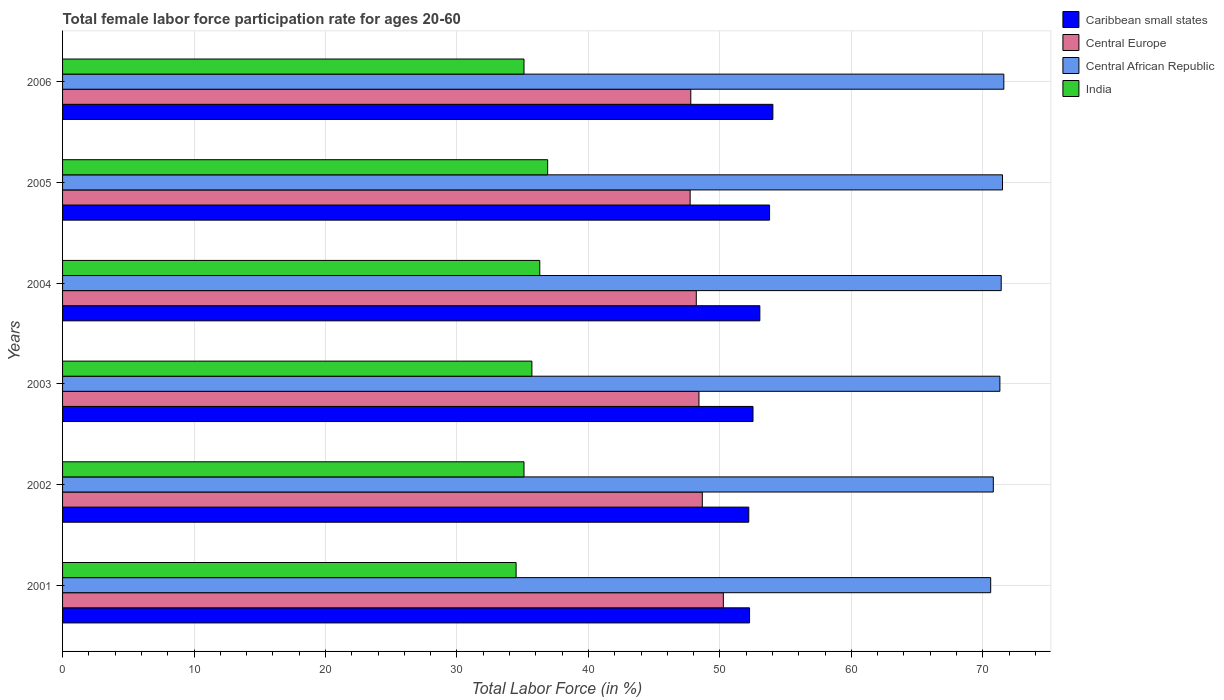How many different coloured bars are there?
Give a very brief answer. 4. Are the number of bars per tick equal to the number of legend labels?
Keep it short and to the point. Yes. Are the number of bars on each tick of the Y-axis equal?
Make the answer very short. Yes. In how many cases, is the number of bars for a given year not equal to the number of legend labels?
Your answer should be compact. 0. What is the female labor force participation rate in Central Europe in 2002?
Your answer should be compact. 48.66. Across all years, what is the maximum female labor force participation rate in Caribbean small states?
Keep it short and to the point. 54.03. Across all years, what is the minimum female labor force participation rate in Central Europe?
Make the answer very short. 47.74. What is the total female labor force participation rate in Central African Republic in the graph?
Provide a short and direct response. 427.2. What is the difference between the female labor force participation rate in Caribbean small states in 2003 and that in 2005?
Provide a succinct answer. -1.26. What is the difference between the female labor force participation rate in Caribbean small states in 2004 and the female labor force participation rate in Central African Republic in 2002?
Provide a short and direct response. -17.76. What is the average female labor force participation rate in Caribbean small states per year?
Make the answer very short. 52.97. In the year 2003, what is the difference between the female labor force participation rate in Central African Republic and female labor force participation rate in India?
Your response must be concise. 35.6. What is the ratio of the female labor force participation rate in India in 2001 to that in 2006?
Keep it short and to the point. 0.98. Is the female labor force participation rate in Central Europe in 2004 less than that in 2005?
Your response must be concise. No. Is the difference between the female labor force participation rate in Central African Republic in 2003 and 2005 greater than the difference between the female labor force participation rate in India in 2003 and 2005?
Provide a succinct answer. Yes. What is the difference between the highest and the second highest female labor force participation rate in India?
Provide a short and direct response. 0.6. What is the difference between the highest and the lowest female labor force participation rate in India?
Provide a short and direct response. 2.4. In how many years, is the female labor force participation rate in Central Europe greater than the average female labor force participation rate in Central Europe taken over all years?
Your answer should be very brief. 2. Is the sum of the female labor force participation rate in India in 2001 and 2005 greater than the maximum female labor force participation rate in Caribbean small states across all years?
Offer a very short reply. Yes. What does the 3rd bar from the top in 2005 represents?
Your answer should be compact. Central Europe. What does the 1st bar from the bottom in 2004 represents?
Your response must be concise. Caribbean small states. Is it the case that in every year, the sum of the female labor force participation rate in Central African Republic and female labor force participation rate in Central Europe is greater than the female labor force participation rate in India?
Your answer should be compact. Yes. Are all the bars in the graph horizontal?
Give a very brief answer. Yes. How many legend labels are there?
Offer a terse response. 4. What is the title of the graph?
Offer a very short reply. Total female labor force participation rate for ages 20-60. Does "Qatar" appear as one of the legend labels in the graph?
Provide a short and direct response. No. What is the label or title of the Y-axis?
Ensure brevity in your answer.  Years. What is the Total Labor Force (in %) in Caribbean small states in 2001?
Your answer should be compact. 52.26. What is the Total Labor Force (in %) in Central Europe in 2001?
Ensure brevity in your answer.  50.26. What is the Total Labor Force (in %) in Central African Republic in 2001?
Ensure brevity in your answer.  70.6. What is the Total Labor Force (in %) of India in 2001?
Your response must be concise. 34.5. What is the Total Labor Force (in %) in Caribbean small states in 2002?
Offer a very short reply. 52.2. What is the Total Labor Force (in %) of Central Europe in 2002?
Give a very brief answer. 48.66. What is the Total Labor Force (in %) in Central African Republic in 2002?
Offer a terse response. 70.8. What is the Total Labor Force (in %) of India in 2002?
Make the answer very short. 35.1. What is the Total Labor Force (in %) of Caribbean small states in 2003?
Your answer should be very brief. 52.52. What is the Total Labor Force (in %) in Central Europe in 2003?
Provide a short and direct response. 48.41. What is the Total Labor Force (in %) of Central African Republic in 2003?
Ensure brevity in your answer.  71.3. What is the Total Labor Force (in %) in India in 2003?
Offer a terse response. 35.7. What is the Total Labor Force (in %) of Caribbean small states in 2004?
Provide a succinct answer. 53.04. What is the Total Labor Force (in %) of Central Europe in 2004?
Make the answer very short. 48.21. What is the Total Labor Force (in %) in Central African Republic in 2004?
Make the answer very short. 71.4. What is the Total Labor Force (in %) in India in 2004?
Provide a short and direct response. 36.3. What is the Total Labor Force (in %) of Caribbean small states in 2005?
Make the answer very short. 53.78. What is the Total Labor Force (in %) in Central Europe in 2005?
Provide a short and direct response. 47.74. What is the Total Labor Force (in %) in Central African Republic in 2005?
Give a very brief answer. 71.5. What is the Total Labor Force (in %) of India in 2005?
Offer a terse response. 36.9. What is the Total Labor Force (in %) in Caribbean small states in 2006?
Offer a very short reply. 54.03. What is the Total Labor Force (in %) of Central Europe in 2006?
Offer a terse response. 47.79. What is the Total Labor Force (in %) in Central African Republic in 2006?
Offer a terse response. 71.6. What is the Total Labor Force (in %) of India in 2006?
Keep it short and to the point. 35.1. Across all years, what is the maximum Total Labor Force (in %) of Caribbean small states?
Keep it short and to the point. 54.03. Across all years, what is the maximum Total Labor Force (in %) of Central Europe?
Make the answer very short. 50.26. Across all years, what is the maximum Total Labor Force (in %) of Central African Republic?
Give a very brief answer. 71.6. Across all years, what is the maximum Total Labor Force (in %) in India?
Keep it short and to the point. 36.9. Across all years, what is the minimum Total Labor Force (in %) in Caribbean small states?
Your answer should be very brief. 52.2. Across all years, what is the minimum Total Labor Force (in %) in Central Europe?
Offer a very short reply. 47.74. Across all years, what is the minimum Total Labor Force (in %) of Central African Republic?
Your answer should be very brief. 70.6. Across all years, what is the minimum Total Labor Force (in %) of India?
Make the answer very short. 34.5. What is the total Total Labor Force (in %) of Caribbean small states in the graph?
Offer a terse response. 317.83. What is the total Total Labor Force (in %) of Central Europe in the graph?
Your answer should be compact. 291.07. What is the total Total Labor Force (in %) in Central African Republic in the graph?
Ensure brevity in your answer.  427.2. What is the total Total Labor Force (in %) in India in the graph?
Keep it short and to the point. 213.6. What is the difference between the Total Labor Force (in %) in Caribbean small states in 2001 and that in 2002?
Your answer should be very brief. 0.06. What is the difference between the Total Labor Force (in %) in Central Europe in 2001 and that in 2002?
Your answer should be very brief. 1.6. What is the difference between the Total Labor Force (in %) in Central African Republic in 2001 and that in 2002?
Provide a succinct answer. -0.2. What is the difference between the Total Labor Force (in %) in Caribbean small states in 2001 and that in 2003?
Keep it short and to the point. -0.26. What is the difference between the Total Labor Force (in %) of Central Europe in 2001 and that in 2003?
Your answer should be compact. 1.86. What is the difference between the Total Labor Force (in %) of India in 2001 and that in 2003?
Provide a short and direct response. -1.2. What is the difference between the Total Labor Force (in %) in Caribbean small states in 2001 and that in 2004?
Make the answer very short. -0.78. What is the difference between the Total Labor Force (in %) of Central Europe in 2001 and that in 2004?
Your answer should be very brief. 2.06. What is the difference between the Total Labor Force (in %) of Central African Republic in 2001 and that in 2004?
Your answer should be compact. -0.8. What is the difference between the Total Labor Force (in %) in Caribbean small states in 2001 and that in 2005?
Give a very brief answer. -1.52. What is the difference between the Total Labor Force (in %) of Central Europe in 2001 and that in 2005?
Provide a succinct answer. 2.53. What is the difference between the Total Labor Force (in %) in Caribbean small states in 2001 and that in 2006?
Keep it short and to the point. -1.77. What is the difference between the Total Labor Force (in %) of Central Europe in 2001 and that in 2006?
Provide a short and direct response. 2.48. What is the difference between the Total Labor Force (in %) of Central African Republic in 2001 and that in 2006?
Give a very brief answer. -1. What is the difference between the Total Labor Force (in %) of India in 2001 and that in 2006?
Ensure brevity in your answer.  -0.6. What is the difference between the Total Labor Force (in %) in Caribbean small states in 2002 and that in 2003?
Your response must be concise. -0.32. What is the difference between the Total Labor Force (in %) of Central Europe in 2002 and that in 2003?
Ensure brevity in your answer.  0.25. What is the difference between the Total Labor Force (in %) of Central African Republic in 2002 and that in 2003?
Offer a very short reply. -0.5. What is the difference between the Total Labor Force (in %) of Caribbean small states in 2002 and that in 2004?
Keep it short and to the point. -0.84. What is the difference between the Total Labor Force (in %) in Central Europe in 2002 and that in 2004?
Offer a very short reply. 0.46. What is the difference between the Total Labor Force (in %) of Caribbean small states in 2002 and that in 2005?
Keep it short and to the point. -1.58. What is the difference between the Total Labor Force (in %) in Central Europe in 2002 and that in 2005?
Offer a very short reply. 0.92. What is the difference between the Total Labor Force (in %) in Central African Republic in 2002 and that in 2005?
Your answer should be very brief. -0.7. What is the difference between the Total Labor Force (in %) of India in 2002 and that in 2005?
Your answer should be very brief. -1.8. What is the difference between the Total Labor Force (in %) in Caribbean small states in 2002 and that in 2006?
Provide a short and direct response. -1.83. What is the difference between the Total Labor Force (in %) in Central Europe in 2002 and that in 2006?
Your answer should be very brief. 0.87. What is the difference between the Total Labor Force (in %) in India in 2002 and that in 2006?
Offer a terse response. 0. What is the difference between the Total Labor Force (in %) in Caribbean small states in 2003 and that in 2004?
Your answer should be compact. -0.52. What is the difference between the Total Labor Force (in %) in Central Europe in 2003 and that in 2004?
Make the answer very short. 0.2. What is the difference between the Total Labor Force (in %) in India in 2003 and that in 2004?
Offer a terse response. -0.6. What is the difference between the Total Labor Force (in %) of Caribbean small states in 2003 and that in 2005?
Provide a succinct answer. -1.26. What is the difference between the Total Labor Force (in %) in Central Europe in 2003 and that in 2005?
Provide a succinct answer. 0.67. What is the difference between the Total Labor Force (in %) of Central African Republic in 2003 and that in 2005?
Keep it short and to the point. -0.2. What is the difference between the Total Labor Force (in %) in Caribbean small states in 2003 and that in 2006?
Offer a very short reply. -1.51. What is the difference between the Total Labor Force (in %) in Central Europe in 2003 and that in 2006?
Offer a terse response. 0.62. What is the difference between the Total Labor Force (in %) in Central African Republic in 2003 and that in 2006?
Offer a very short reply. -0.3. What is the difference between the Total Labor Force (in %) in India in 2003 and that in 2006?
Your answer should be very brief. 0.6. What is the difference between the Total Labor Force (in %) of Caribbean small states in 2004 and that in 2005?
Give a very brief answer. -0.74. What is the difference between the Total Labor Force (in %) in Central Europe in 2004 and that in 2005?
Offer a very short reply. 0.47. What is the difference between the Total Labor Force (in %) of Caribbean small states in 2004 and that in 2006?
Provide a short and direct response. -0.99. What is the difference between the Total Labor Force (in %) of Central Europe in 2004 and that in 2006?
Make the answer very short. 0.42. What is the difference between the Total Labor Force (in %) in Caribbean small states in 2005 and that in 2006?
Give a very brief answer. -0.25. What is the difference between the Total Labor Force (in %) of Central Europe in 2005 and that in 2006?
Your response must be concise. -0.05. What is the difference between the Total Labor Force (in %) in Caribbean small states in 2001 and the Total Labor Force (in %) in Central Europe in 2002?
Offer a terse response. 3.6. What is the difference between the Total Labor Force (in %) in Caribbean small states in 2001 and the Total Labor Force (in %) in Central African Republic in 2002?
Provide a succinct answer. -18.54. What is the difference between the Total Labor Force (in %) in Caribbean small states in 2001 and the Total Labor Force (in %) in India in 2002?
Your response must be concise. 17.16. What is the difference between the Total Labor Force (in %) in Central Europe in 2001 and the Total Labor Force (in %) in Central African Republic in 2002?
Your answer should be compact. -20.54. What is the difference between the Total Labor Force (in %) of Central Europe in 2001 and the Total Labor Force (in %) of India in 2002?
Provide a succinct answer. 15.16. What is the difference between the Total Labor Force (in %) in Central African Republic in 2001 and the Total Labor Force (in %) in India in 2002?
Provide a succinct answer. 35.5. What is the difference between the Total Labor Force (in %) of Caribbean small states in 2001 and the Total Labor Force (in %) of Central Europe in 2003?
Provide a short and direct response. 3.85. What is the difference between the Total Labor Force (in %) of Caribbean small states in 2001 and the Total Labor Force (in %) of Central African Republic in 2003?
Your answer should be compact. -19.04. What is the difference between the Total Labor Force (in %) of Caribbean small states in 2001 and the Total Labor Force (in %) of India in 2003?
Make the answer very short. 16.56. What is the difference between the Total Labor Force (in %) in Central Europe in 2001 and the Total Labor Force (in %) in Central African Republic in 2003?
Provide a succinct answer. -21.04. What is the difference between the Total Labor Force (in %) in Central Europe in 2001 and the Total Labor Force (in %) in India in 2003?
Keep it short and to the point. 14.56. What is the difference between the Total Labor Force (in %) of Central African Republic in 2001 and the Total Labor Force (in %) of India in 2003?
Provide a succinct answer. 34.9. What is the difference between the Total Labor Force (in %) in Caribbean small states in 2001 and the Total Labor Force (in %) in Central Europe in 2004?
Your answer should be very brief. 4.05. What is the difference between the Total Labor Force (in %) in Caribbean small states in 2001 and the Total Labor Force (in %) in Central African Republic in 2004?
Keep it short and to the point. -19.14. What is the difference between the Total Labor Force (in %) in Caribbean small states in 2001 and the Total Labor Force (in %) in India in 2004?
Your response must be concise. 15.96. What is the difference between the Total Labor Force (in %) in Central Europe in 2001 and the Total Labor Force (in %) in Central African Republic in 2004?
Provide a short and direct response. -21.14. What is the difference between the Total Labor Force (in %) of Central Europe in 2001 and the Total Labor Force (in %) of India in 2004?
Offer a very short reply. 13.96. What is the difference between the Total Labor Force (in %) of Central African Republic in 2001 and the Total Labor Force (in %) of India in 2004?
Ensure brevity in your answer.  34.3. What is the difference between the Total Labor Force (in %) of Caribbean small states in 2001 and the Total Labor Force (in %) of Central Europe in 2005?
Provide a short and direct response. 4.52. What is the difference between the Total Labor Force (in %) in Caribbean small states in 2001 and the Total Labor Force (in %) in Central African Republic in 2005?
Your answer should be compact. -19.24. What is the difference between the Total Labor Force (in %) of Caribbean small states in 2001 and the Total Labor Force (in %) of India in 2005?
Provide a succinct answer. 15.36. What is the difference between the Total Labor Force (in %) of Central Europe in 2001 and the Total Labor Force (in %) of Central African Republic in 2005?
Provide a short and direct response. -21.24. What is the difference between the Total Labor Force (in %) in Central Europe in 2001 and the Total Labor Force (in %) in India in 2005?
Provide a succinct answer. 13.36. What is the difference between the Total Labor Force (in %) in Central African Republic in 2001 and the Total Labor Force (in %) in India in 2005?
Give a very brief answer. 33.7. What is the difference between the Total Labor Force (in %) of Caribbean small states in 2001 and the Total Labor Force (in %) of Central Europe in 2006?
Make the answer very short. 4.47. What is the difference between the Total Labor Force (in %) in Caribbean small states in 2001 and the Total Labor Force (in %) in Central African Republic in 2006?
Provide a succinct answer. -19.34. What is the difference between the Total Labor Force (in %) in Caribbean small states in 2001 and the Total Labor Force (in %) in India in 2006?
Your answer should be very brief. 17.16. What is the difference between the Total Labor Force (in %) in Central Europe in 2001 and the Total Labor Force (in %) in Central African Republic in 2006?
Offer a very short reply. -21.34. What is the difference between the Total Labor Force (in %) of Central Europe in 2001 and the Total Labor Force (in %) of India in 2006?
Your answer should be compact. 15.16. What is the difference between the Total Labor Force (in %) of Central African Republic in 2001 and the Total Labor Force (in %) of India in 2006?
Your answer should be very brief. 35.5. What is the difference between the Total Labor Force (in %) of Caribbean small states in 2002 and the Total Labor Force (in %) of Central Europe in 2003?
Make the answer very short. 3.79. What is the difference between the Total Labor Force (in %) in Caribbean small states in 2002 and the Total Labor Force (in %) in Central African Republic in 2003?
Your answer should be compact. -19.1. What is the difference between the Total Labor Force (in %) in Caribbean small states in 2002 and the Total Labor Force (in %) in India in 2003?
Offer a very short reply. 16.5. What is the difference between the Total Labor Force (in %) in Central Europe in 2002 and the Total Labor Force (in %) in Central African Republic in 2003?
Provide a succinct answer. -22.64. What is the difference between the Total Labor Force (in %) in Central Europe in 2002 and the Total Labor Force (in %) in India in 2003?
Offer a terse response. 12.96. What is the difference between the Total Labor Force (in %) of Central African Republic in 2002 and the Total Labor Force (in %) of India in 2003?
Ensure brevity in your answer.  35.1. What is the difference between the Total Labor Force (in %) of Caribbean small states in 2002 and the Total Labor Force (in %) of Central Europe in 2004?
Make the answer very short. 3.99. What is the difference between the Total Labor Force (in %) of Caribbean small states in 2002 and the Total Labor Force (in %) of Central African Republic in 2004?
Offer a terse response. -19.2. What is the difference between the Total Labor Force (in %) of Caribbean small states in 2002 and the Total Labor Force (in %) of India in 2004?
Provide a short and direct response. 15.9. What is the difference between the Total Labor Force (in %) in Central Europe in 2002 and the Total Labor Force (in %) in Central African Republic in 2004?
Your answer should be very brief. -22.74. What is the difference between the Total Labor Force (in %) in Central Europe in 2002 and the Total Labor Force (in %) in India in 2004?
Your response must be concise. 12.36. What is the difference between the Total Labor Force (in %) in Central African Republic in 2002 and the Total Labor Force (in %) in India in 2004?
Ensure brevity in your answer.  34.5. What is the difference between the Total Labor Force (in %) of Caribbean small states in 2002 and the Total Labor Force (in %) of Central Europe in 2005?
Provide a succinct answer. 4.46. What is the difference between the Total Labor Force (in %) in Caribbean small states in 2002 and the Total Labor Force (in %) in Central African Republic in 2005?
Your response must be concise. -19.3. What is the difference between the Total Labor Force (in %) of Caribbean small states in 2002 and the Total Labor Force (in %) of India in 2005?
Offer a terse response. 15.3. What is the difference between the Total Labor Force (in %) of Central Europe in 2002 and the Total Labor Force (in %) of Central African Republic in 2005?
Offer a very short reply. -22.84. What is the difference between the Total Labor Force (in %) in Central Europe in 2002 and the Total Labor Force (in %) in India in 2005?
Provide a succinct answer. 11.76. What is the difference between the Total Labor Force (in %) of Central African Republic in 2002 and the Total Labor Force (in %) of India in 2005?
Provide a short and direct response. 33.9. What is the difference between the Total Labor Force (in %) in Caribbean small states in 2002 and the Total Labor Force (in %) in Central Europe in 2006?
Ensure brevity in your answer.  4.41. What is the difference between the Total Labor Force (in %) in Caribbean small states in 2002 and the Total Labor Force (in %) in Central African Republic in 2006?
Your answer should be compact. -19.4. What is the difference between the Total Labor Force (in %) of Caribbean small states in 2002 and the Total Labor Force (in %) of India in 2006?
Provide a succinct answer. 17.1. What is the difference between the Total Labor Force (in %) in Central Europe in 2002 and the Total Labor Force (in %) in Central African Republic in 2006?
Keep it short and to the point. -22.94. What is the difference between the Total Labor Force (in %) of Central Europe in 2002 and the Total Labor Force (in %) of India in 2006?
Ensure brevity in your answer.  13.56. What is the difference between the Total Labor Force (in %) in Central African Republic in 2002 and the Total Labor Force (in %) in India in 2006?
Make the answer very short. 35.7. What is the difference between the Total Labor Force (in %) in Caribbean small states in 2003 and the Total Labor Force (in %) in Central Europe in 2004?
Offer a terse response. 4.31. What is the difference between the Total Labor Force (in %) in Caribbean small states in 2003 and the Total Labor Force (in %) in Central African Republic in 2004?
Ensure brevity in your answer.  -18.88. What is the difference between the Total Labor Force (in %) in Caribbean small states in 2003 and the Total Labor Force (in %) in India in 2004?
Ensure brevity in your answer.  16.22. What is the difference between the Total Labor Force (in %) of Central Europe in 2003 and the Total Labor Force (in %) of Central African Republic in 2004?
Give a very brief answer. -22.99. What is the difference between the Total Labor Force (in %) of Central Europe in 2003 and the Total Labor Force (in %) of India in 2004?
Give a very brief answer. 12.11. What is the difference between the Total Labor Force (in %) of Central African Republic in 2003 and the Total Labor Force (in %) of India in 2004?
Give a very brief answer. 35. What is the difference between the Total Labor Force (in %) of Caribbean small states in 2003 and the Total Labor Force (in %) of Central Europe in 2005?
Your answer should be compact. 4.78. What is the difference between the Total Labor Force (in %) of Caribbean small states in 2003 and the Total Labor Force (in %) of Central African Republic in 2005?
Your response must be concise. -18.98. What is the difference between the Total Labor Force (in %) of Caribbean small states in 2003 and the Total Labor Force (in %) of India in 2005?
Ensure brevity in your answer.  15.62. What is the difference between the Total Labor Force (in %) in Central Europe in 2003 and the Total Labor Force (in %) in Central African Republic in 2005?
Your answer should be compact. -23.09. What is the difference between the Total Labor Force (in %) in Central Europe in 2003 and the Total Labor Force (in %) in India in 2005?
Your response must be concise. 11.51. What is the difference between the Total Labor Force (in %) of Central African Republic in 2003 and the Total Labor Force (in %) of India in 2005?
Keep it short and to the point. 34.4. What is the difference between the Total Labor Force (in %) in Caribbean small states in 2003 and the Total Labor Force (in %) in Central Europe in 2006?
Offer a terse response. 4.73. What is the difference between the Total Labor Force (in %) in Caribbean small states in 2003 and the Total Labor Force (in %) in Central African Republic in 2006?
Keep it short and to the point. -19.08. What is the difference between the Total Labor Force (in %) of Caribbean small states in 2003 and the Total Labor Force (in %) of India in 2006?
Keep it short and to the point. 17.42. What is the difference between the Total Labor Force (in %) in Central Europe in 2003 and the Total Labor Force (in %) in Central African Republic in 2006?
Give a very brief answer. -23.19. What is the difference between the Total Labor Force (in %) of Central Europe in 2003 and the Total Labor Force (in %) of India in 2006?
Provide a succinct answer. 13.31. What is the difference between the Total Labor Force (in %) in Central African Republic in 2003 and the Total Labor Force (in %) in India in 2006?
Your response must be concise. 36.2. What is the difference between the Total Labor Force (in %) in Caribbean small states in 2004 and the Total Labor Force (in %) in Central Europe in 2005?
Offer a terse response. 5.3. What is the difference between the Total Labor Force (in %) of Caribbean small states in 2004 and the Total Labor Force (in %) of Central African Republic in 2005?
Offer a terse response. -18.46. What is the difference between the Total Labor Force (in %) of Caribbean small states in 2004 and the Total Labor Force (in %) of India in 2005?
Give a very brief answer. 16.14. What is the difference between the Total Labor Force (in %) of Central Europe in 2004 and the Total Labor Force (in %) of Central African Republic in 2005?
Give a very brief answer. -23.29. What is the difference between the Total Labor Force (in %) of Central Europe in 2004 and the Total Labor Force (in %) of India in 2005?
Ensure brevity in your answer.  11.31. What is the difference between the Total Labor Force (in %) of Central African Republic in 2004 and the Total Labor Force (in %) of India in 2005?
Keep it short and to the point. 34.5. What is the difference between the Total Labor Force (in %) in Caribbean small states in 2004 and the Total Labor Force (in %) in Central Europe in 2006?
Your answer should be very brief. 5.25. What is the difference between the Total Labor Force (in %) in Caribbean small states in 2004 and the Total Labor Force (in %) in Central African Republic in 2006?
Ensure brevity in your answer.  -18.56. What is the difference between the Total Labor Force (in %) in Caribbean small states in 2004 and the Total Labor Force (in %) in India in 2006?
Provide a succinct answer. 17.94. What is the difference between the Total Labor Force (in %) in Central Europe in 2004 and the Total Labor Force (in %) in Central African Republic in 2006?
Offer a terse response. -23.39. What is the difference between the Total Labor Force (in %) in Central Europe in 2004 and the Total Labor Force (in %) in India in 2006?
Give a very brief answer. 13.11. What is the difference between the Total Labor Force (in %) in Central African Republic in 2004 and the Total Labor Force (in %) in India in 2006?
Your response must be concise. 36.3. What is the difference between the Total Labor Force (in %) in Caribbean small states in 2005 and the Total Labor Force (in %) in Central Europe in 2006?
Ensure brevity in your answer.  5.99. What is the difference between the Total Labor Force (in %) in Caribbean small states in 2005 and the Total Labor Force (in %) in Central African Republic in 2006?
Your answer should be compact. -17.82. What is the difference between the Total Labor Force (in %) in Caribbean small states in 2005 and the Total Labor Force (in %) in India in 2006?
Give a very brief answer. 18.68. What is the difference between the Total Labor Force (in %) in Central Europe in 2005 and the Total Labor Force (in %) in Central African Republic in 2006?
Offer a terse response. -23.86. What is the difference between the Total Labor Force (in %) in Central Europe in 2005 and the Total Labor Force (in %) in India in 2006?
Offer a very short reply. 12.64. What is the difference between the Total Labor Force (in %) of Central African Republic in 2005 and the Total Labor Force (in %) of India in 2006?
Offer a terse response. 36.4. What is the average Total Labor Force (in %) of Caribbean small states per year?
Give a very brief answer. 52.97. What is the average Total Labor Force (in %) of Central Europe per year?
Your answer should be very brief. 48.51. What is the average Total Labor Force (in %) of Central African Republic per year?
Provide a short and direct response. 71.2. What is the average Total Labor Force (in %) in India per year?
Provide a succinct answer. 35.6. In the year 2001, what is the difference between the Total Labor Force (in %) of Caribbean small states and Total Labor Force (in %) of Central Europe?
Your answer should be compact. 1.99. In the year 2001, what is the difference between the Total Labor Force (in %) of Caribbean small states and Total Labor Force (in %) of Central African Republic?
Offer a terse response. -18.34. In the year 2001, what is the difference between the Total Labor Force (in %) of Caribbean small states and Total Labor Force (in %) of India?
Provide a short and direct response. 17.76. In the year 2001, what is the difference between the Total Labor Force (in %) in Central Europe and Total Labor Force (in %) in Central African Republic?
Your answer should be compact. -20.34. In the year 2001, what is the difference between the Total Labor Force (in %) in Central Europe and Total Labor Force (in %) in India?
Provide a succinct answer. 15.76. In the year 2001, what is the difference between the Total Labor Force (in %) in Central African Republic and Total Labor Force (in %) in India?
Your answer should be very brief. 36.1. In the year 2002, what is the difference between the Total Labor Force (in %) of Caribbean small states and Total Labor Force (in %) of Central Europe?
Your answer should be compact. 3.54. In the year 2002, what is the difference between the Total Labor Force (in %) in Caribbean small states and Total Labor Force (in %) in Central African Republic?
Your response must be concise. -18.6. In the year 2002, what is the difference between the Total Labor Force (in %) in Caribbean small states and Total Labor Force (in %) in India?
Provide a succinct answer. 17.1. In the year 2002, what is the difference between the Total Labor Force (in %) of Central Europe and Total Labor Force (in %) of Central African Republic?
Give a very brief answer. -22.14. In the year 2002, what is the difference between the Total Labor Force (in %) in Central Europe and Total Labor Force (in %) in India?
Keep it short and to the point. 13.56. In the year 2002, what is the difference between the Total Labor Force (in %) of Central African Republic and Total Labor Force (in %) of India?
Give a very brief answer. 35.7. In the year 2003, what is the difference between the Total Labor Force (in %) of Caribbean small states and Total Labor Force (in %) of Central Europe?
Your answer should be compact. 4.11. In the year 2003, what is the difference between the Total Labor Force (in %) in Caribbean small states and Total Labor Force (in %) in Central African Republic?
Provide a short and direct response. -18.78. In the year 2003, what is the difference between the Total Labor Force (in %) of Caribbean small states and Total Labor Force (in %) of India?
Offer a terse response. 16.82. In the year 2003, what is the difference between the Total Labor Force (in %) in Central Europe and Total Labor Force (in %) in Central African Republic?
Offer a very short reply. -22.89. In the year 2003, what is the difference between the Total Labor Force (in %) of Central Europe and Total Labor Force (in %) of India?
Offer a very short reply. 12.71. In the year 2003, what is the difference between the Total Labor Force (in %) of Central African Republic and Total Labor Force (in %) of India?
Keep it short and to the point. 35.6. In the year 2004, what is the difference between the Total Labor Force (in %) of Caribbean small states and Total Labor Force (in %) of Central Europe?
Offer a very short reply. 4.83. In the year 2004, what is the difference between the Total Labor Force (in %) in Caribbean small states and Total Labor Force (in %) in Central African Republic?
Keep it short and to the point. -18.36. In the year 2004, what is the difference between the Total Labor Force (in %) of Caribbean small states and Total Labor Force (in %) of India?
Give a very brief answer. 16.74. In the year 2004, what is the difference between the Total Labor Force (in %) of Central Europe and Total Labor Force (in %) of Central African Republic?
Offer a terse response. -23.19. In the year 2004, what is the difference between the Total Labor Force (in %) of Central Europe and Total Labor Force (in %) of India?
Keep it short and to the point. 11.91. In the year 2004, what is the difference between the Total Labor Force (in %) in Central African Republic and Total Labor Force (in %) in India?
Give a very brief answer. 35.1. In the year 2005, what is the difference between the Total Labor Force (in %) of Caribbean small states and Total Labor Force (in %) of Central Europe?
Offer a very short reply. 6.04. In the year 2005, what is the difference between the Total Labor Force (in %) of Caribbean small states and Total Labor Force (in %) of Central African Republic?
Keep it short and to the point. -17.72. In the year 2005, what is the difference between the Total Labor Force (in %) of Caribbean small states and Total Labor Force (in %) of India?
Your response must be concise. 16.88. In the year 2005, what is the difference between the Total Labor Force (in %) of Central Europe and Total Labor Force (in %) of Central African Republic?
Make the answer very short. -23.76. In the year 2005, what is the difference between the Total Labor Force (in %) of Central Europe and Total Labor Force (in %) of India?
Offer a terse response. 10.84. In the year 2005, what is the difference between the Total Labor Force (in %) of Central African Republic and Total Labor Force (in %) of India?
Make the answer very short. 34.6. In the year 2006, what is the difference between the Total Labor Force (in %) of Caribbean small states and Total Labor Force (in %) of Central Europe?
Keep it short and to the point. 6.24. In the year 2006, what is the difference between the Total Labor Force (in %) in Caribbean small states and Total Labor Force (in %) in Central African Republic?
Your response must be concise. -17.57. In the year 2006, what is the difference between the Total Labor Force (in %) in Caribbean small states and Total Labor Force (in %) in India?
Ensure brevity in your answer.  18.93. In the year 2006, what is the difference between the Total Labor Force (in %) in Central Europe and Total Labor Force (in %) in Central African Republic?
Provide a short and direct response. -23.81. In the year 2006, what is the difference between the Total Labor Force (in %) in Central Europe and Total Labor Force (in %) in India?
Ensure brevity in your answer.  12.69. In the year 2006, what is the difference between the Total Labor Force (in %) in Central African Republic and Total Labor Force (in %) in India?
Ensure brevity in your answer.  36.5. What is the ratio of the Total Labor Force (in %) of Central Europe in 2001 to that in 2002?
Offer a terse response. 1.03. What is the ratio of the Total Labor Force (in %) in Central African Republic in 2001 to that in 2002?
Keep it short and to the point. 1. What is the ratio of the Total Labor Force (in %) in India in 2001 to that in 2002?
Your answer should be very brief. 0.98. What is the ratio of the Total Labor Force (in %) of Central Europe in 2001 to that in 2003?
Offer a terse response. 1.04. What is the ratio of the Total Labor Force (in %) in Central African Republic in 2001 to that in 2003?
Your answer should be very brief. 0.99. What is the ratio of the Total Labor Force (in %) of India in 2001 to that in 2003?
Provide a succinct answer. 0.97. What is the ratio of the Total Labor Force (in %) of Caribbean small states in 2001 to that in 2004?
Offer a terse response. 0.99. What is the ratio of the Total Labor Force (in %) of Central Europe in 2001 to that in 2004?
Provide a short and direct response. 1.04. What is the ratio of the Total Labor Force (in %) of Central African Republic in 2001 to that in 2004?
Your response must be concise. 0.99. What is the ratio of the Total Labor Force (in %) in India in 2001 to that in 2004?
Ensure brevity in your answer.  0.95. What is the ratio of the Total Labor Force (in %) of Caribbean small states in 2001 to that in 2005?
Make the answer very short. 0.97. What is the ratio of the Total Labor Force (in %) in Central Europe in 2001 to that in 2005?
Make the answer very short. 1.05. What is the ratio of the Total Labor Force (in %) in Central African Republic in 2001 to that in 2005?
Provide a succinct answer. 0.99. What is the ratio of the Total Labor Force (in %) of India in 2001 to that in 2005?
Make the answer very short. 0.94. What is the ratio of the Total Labor Force (in %) in Caribbean small states in 2001 to that in 2006?
Your response must be concise. 0.97. What is the ratio of the Total Labor Force (in %) in Central Europe in 2001 to that in 2006?
Your answer should be compact. 1.05. What is the ratio of the Total Labor Force (in %) in India in 2001 to that in 2006?
Give a very brief answer. 0.98. What is the ratio of the Total Labor Force (in %) in Caribbean small states in 2002 to that in 2003?
Provide a short and direct response. 0.99. What is the ratio of the Total Labor Force (in %) in Central Europe in 2002 to that in 2003?
Your answer should be compact. 1.01. What is the ratio of the Total Labor Force (in %) of India in 2002 to that in 2003?
Give a very brief answer. 0.98. What is the ratio of the Total Labor Force (in %) in Caribbean small states in 2002 to that in 2004?
Provide a short and direct response. 0.98. What is the ratio of the Total Labor Force (in %) in Central Europe in 2002 to that in 2004?
Keep it short and to the point. 1.01. What is the ratio of the Total Labor Force (in %) in India in 2002 to that in 2004?
Your answer should be very brief. 0.97. What is the ratio of the Total Labor Force (in %) of Caribbean small states in 2002 to that in 2005?
Provide a succinct answer. 0.97. What is the ratio of the Total Labor Force (in %) of Central Europe in 2002 to that in 2005?
Your answer should be compact. 1.02. What is the ratio of the Total Labor Force (in %) in Central African Republic in 2002 to that in 2005?
Your answer should be very brief. 0.99. What is the ratio of the Total Labor Force (in %) of India in 2002 to that in 2005?
Your answer should be compact. 0.95. What is the ratio of the Total Labor Force (in %) in Caribbean small states in 2002 to that in 2006?
Give a very brief answer. 0.97. What is the ratio of the Total Labor Force (in %) in Central Europe in 2002 to that in 2006?
Ensure brevity in your answer.  1.02. What is the ratio of the Total Labor Force (in %) of Central African Republic in 2002 to that in 2006?
Give a very brief answer. 0.99. What is the ratio of the Total Labor Force (in %) of India in 2002 to that in 2006?
Provide a succinct answer. 1. What is the ratio of the Total Labor Force (in %) of Caribbean small states in 2003 to that in 2004?
Provide a short and direct response. 0.99. What is the ratio of the Total Labor Force (in %) in Central Europe in 2003 to that in 2004?
Offer a very short reply. 1. What is the ratio of the Total Labor Force (in %) in Central African Republic in 2003 to that in 2004?
Make the answer very short. 1. What is the ratio of the Total Labor Force (in %) in India in 2003 to that in 2004?
Make the answer very short. 0.98. What is the ratio of the Total Labor Force (in %) of Caribbean small states in 2003 to that in 2005?
Give a very brief answer. 0.98. What is the ratio of the Total Labor Force (in %) in India in 2003 to that in 2005?
Make the answer very short. 0.97. What is the ratio of the Total Labor Force (in %) in Central African Republic in 2003 to that in 2006?
Provide a short and direct response. 1. What is the ratio of the Total Labor Force (in %) in India in 2003 to that in 2006?
Keep it short and to the point. 1.02. What is the ratio of the Total Labor Force (in %) of Caribbean small states in 2004 to that in 2005?
Your response must be concise. 0.99. What is the ratio of the Total Labor Force (in %) in Central Europe in 2004 to that in 2005?
Offer a terse response. 1.01. What is the ratio of the Total Labor Force (in %) of Central African Republic in 2004 to that in 2005?
Offer a terse response. 1. What is the ratio of the Total Labor Force (in %) in India in 2004 to that in 2005?
Your answer should be very brief. 0.98. What is the ratio of the Total Labor Force (in %) of Caribbean small states in 2004 to that in 2006?
Offer a terse response. 0.98. What is the ratio of the Total Labor Force (in %) in Central Europe in 2004 to that in 2006?
Make the answer very short. 1.01. What is the ratio of the Total Labor Force (in %) in India in 2004 to that in 2006?
Your answer should be compact. 1.03. What is the ratio of the Total Labor Force (in %) of Caribbean small states in 2005 to that in 2006?
Offer a terse response. 1. What is the ratio of the Total Labor Force (in %) of Central Europe in 2005 to that in 2006?
Provide a succinct answer. 1. What is the ratio of the Total Labor Force (in %) of Central African Republic in 2005 to that in 2006?
Keep it short and to the point. 1. What is the ratio of the Total Labor Force (in %) in India in 2005 to that in 2006?
Make the answer very short. 1.05. What is the difference between the highest and the second highest Total Labor Force (in %) of Caribbean small states?
Offer a very short reply. 0.25. What is the difference between the highest and the second highest Total Labor Force (in %) in Central Europe?
Offer a terse response. 1.6. What is the difference between the highest and the second highest Total Labor Force (in %) of India?
Your answer should be very brief. 0.6. What is the difference between the highest and the lowest Total Labor Force (in %) of Caribbean small states?
Your answer should be compact. 1.83. What is the difference between the highest and the lowest Total Labor Force (in %) of Central Europe?
Provide a short and direct response. 2.53. 